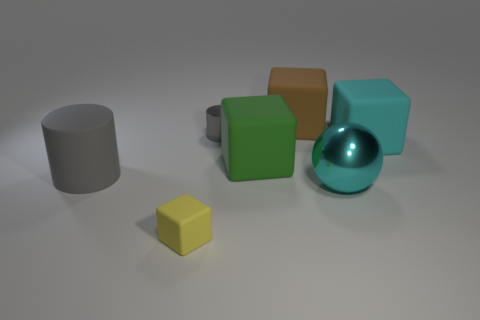The cyan sphere that is right of the gray cylinder that is on the right side of the gray object in front of the small cylinder is made of what material? metal 